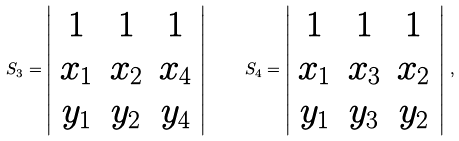<formula> <loc_0><loc_0><loc_500><loc_500>S _ { 3 } = \left | \begin{array} { c c c } 1 & 1 & 1 \\ x _ { 1 } & x _ { 2 } & x _ { 4 } \\ y _ { 1 } & y _ { 2 } & y _ { 4 } \end{array} \right | \, \quad S _ { 4 } = \left | \begin{array} { c c c } 1 & 1 & 1 \\ x _ { 1 } & x _ { 3 } & x _ { 2 } \\ y _ { 1 } & y _ { 3 } & y _ { 2 } \end{array} \right | \, ,</formula> 